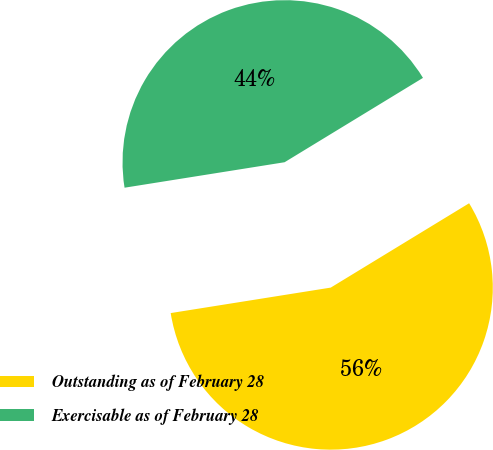Convert chart. <chart><loc_0><loc_0><loc_500><loc_500><pie_chart><fcel>Outstanding as of February 28<fcel>Exercisable as of February 28<nl><fcel>56.2%<fcel>43.8%<nl></chart> 